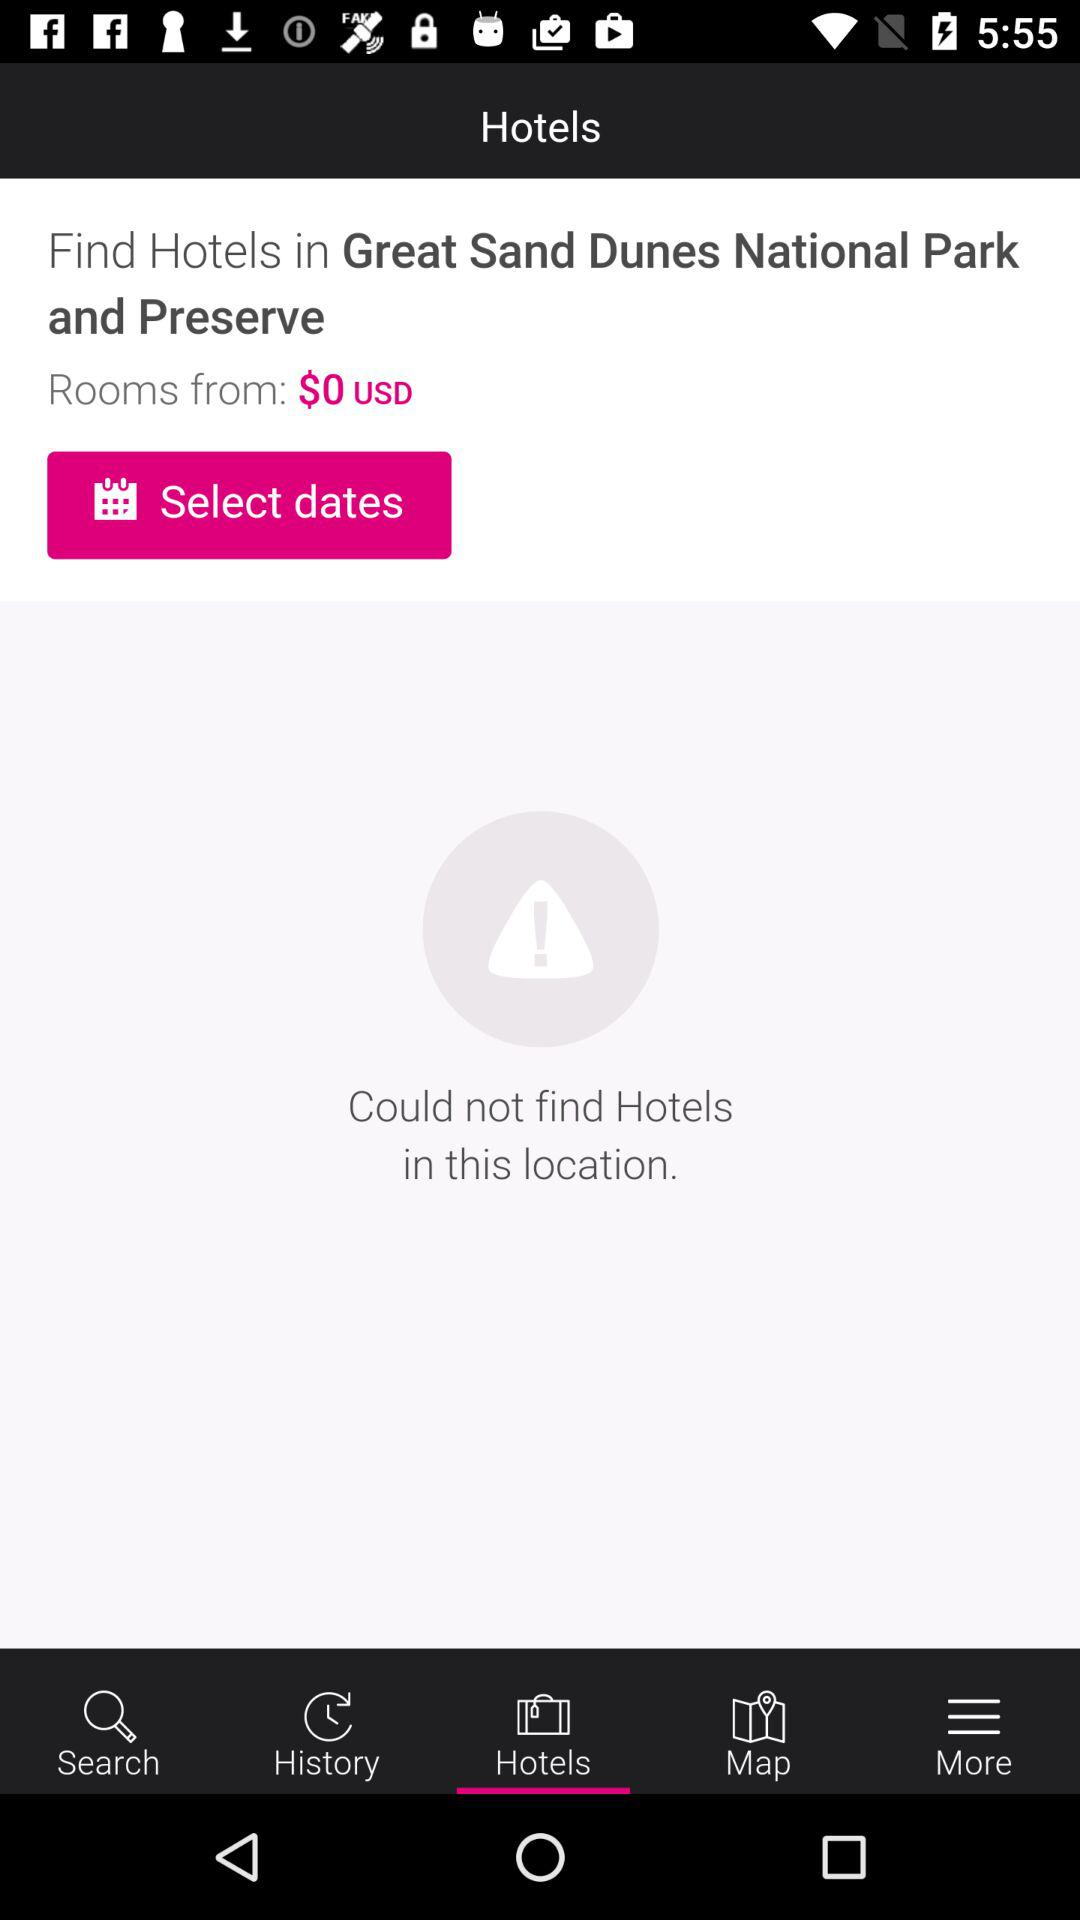Is there any hotel? There is no hotel. 